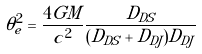Convert formula to latex. <formula><loc_0><loc_0><loc_500><loc_500>\theta ^ { 2 } _ { e } = \frac { 4 G M } { c ^ { 2 } } \frac { D _ { D S } } { ( D _ { D S } + D _ { D J } ) D _ { D J } }</formula> 